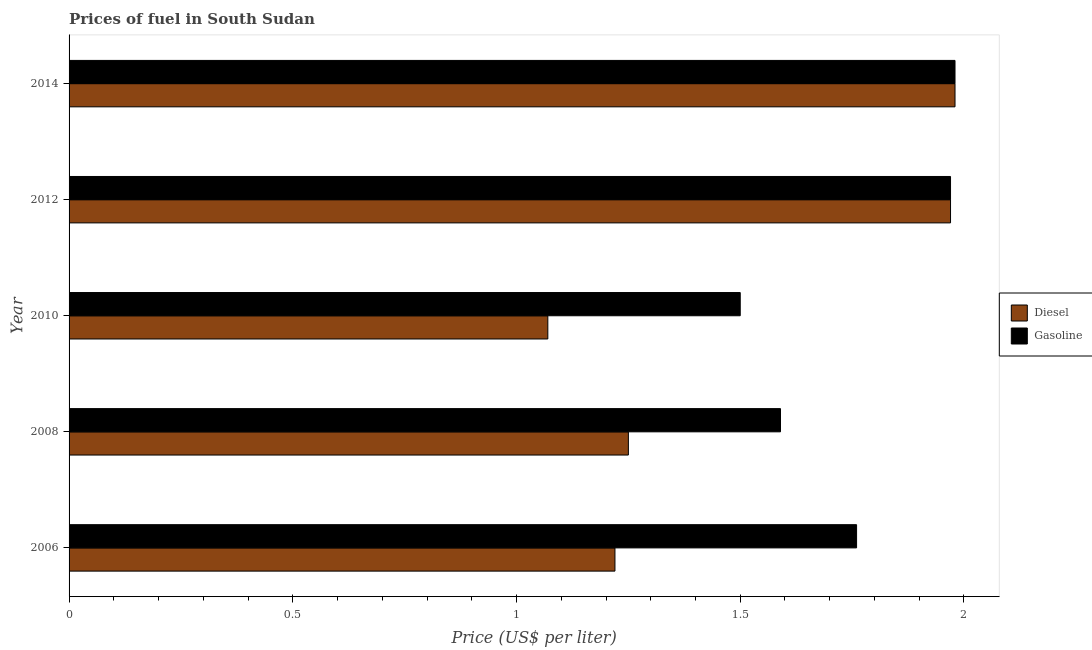How many groups of bars are there?
Your answer should be very brief. 5. Are the number of bars per tick equal to the number of legend labels?
Provide a succinct answer. Yes. How many bars are there on the 2nd tick from the bottom?
Make the answer very short. 2. What is the label of the 5th group of bars from the top?
Keep it short and to the point. 2006. In how many cases, is the number of bars for a given year not equal to the number of legend labels?
Give a very brief answer. 0. What is the diesel price in 2012?
Give a very brief answer. 1.97. Across all years, what is the maximum gasoline price?
Provide a succinct answer. 1.98. Across all years, what is the minimum diesel price?
Offer a terse response. 1.07. In which year was the diesel price minimum?
Make the answer very short. 2010. What is the total gasoline price in the graph?
Make the answer very short. 8.8. What is the difference between the gasoline price in 2012 and that in 2014?
Keep it short and to the point. -0.01. What is the difference between the gasoline price in 2006 and the diesel price in 2010?
Provide a short and direct response. 0.69. What is the average diesel price per year?
Your answer should be compact. 1.5. In the year 2012, what is the difference between the gasoline price and diesel price?
Your response must be concise. 0. In how many years, is the diesel price greater than 1.3 US$ per litre?
Provide a short and direct response. 2. What is the ratio of the diesel price in 2006 to that in 2010?
Ensure brevity in your answer.  1.14. Is the gasoline price in 2006 less than that in 2010?
Make the answer very short. No. Is the difference between the diesel price in 2008 and 2012 greater than the difference between the gasoline price in 2008 and 2012?
Ensure brevity in your answer.  No. What is the difference between the highest and the second highest diesel price?
Your answer should be very brief. 0.01. What is the difference between the highest and the lowest gasoline price?
Your response must be concise. 0.48. In how many years, is the diesel price greater than the average diesel price taken over all years?
Give a very brief answer. 2. What does the 2nd bar from the top in 2014 represents?
Make the answer very short. Diesel. What does the 2nd bar from the bottom in 2012 represents?
Offer a terse response. Gasoline. How many bars are there?
Provide a short and direct response. 10. Are the values on the major ticks of X-axis written in scientific E-notation?
Your answer should be compact. No. Does the graph contain any zero values?
Ensure brevity in your answer.  No. Does the graph contain grids?
Provide a succinct answer. No. How are the legend labels stacked?
Your answer should be compact. Vertical. What is the title of the graph?
Your response must be concise. Prices of fuel in South Sudan. What is the label or title of the X-axis?
Your answer should be very brief. Price (US$ per liter). What is the Price (US$ per liter) in Diesel in 2006?
Your answer should be very brief. 1.22. What is the Price (US$ per liter) in Gasoline in 2006?
Ensure brevity in your answer.  1.76. What is the Price (US$ per liter) of Diesel in 2008?
Offer a terse response. 1.25. What is the Price (US$ per liter) in Gasoline in 2008?
Keep it short and to the point. 1.59. What is the Price (US$ per liter) in Diesel in 2010?
Keep it short and to the point. 1.07. What is the Price (US$ per liter) of Diesel in 2012?
Make the answer very short. 1.97. What is the Price (US$ per liter) of Gasoline in 2012?
Ensure brevity in your answer.  1.97. What is the Price (US$ per liter) of Diesel in 2014?
Your answer should be compact. 1.98. What is the Price (US$ per liter) of Gasoline in 2014?
Keep it short and to the point. 1.98. Across all years, what is the maximum Price (US$ per liter) in Diesel?
Your response must be concise. 1.98. Across all years, what is the maximum Price (US$ per liter) of Gasoline?
Offer a terse response. 1.98. Across all years, what is the minimum Price (US$ per liter) in Diesel?
Provide a short and direct response. 1.07. What is the total Price (US$ per liter) of Diesel in the graph?
Offer a terse response. 7.49. What is the difference between the Price (US$ per liter) of Diesel in 2006 and that in 2008?
Ensure brevity in your answer.  -0.03. What is the difference between the Price (US$ per liter) in Gasoline in 2006 and that in 2008?
Provide a succinct answer. 0.17. What is the difference between the Price (US$ per liter) in Gasoline in 2006 and that in 2010?
Keep it short and to the point. 0.26. What is the difference between the Price (US$ per liter) in Diesel in 2006 and that in 2012?
Ensure brevity in your answer.  -0.75. What is the difference between the Price (US$ per liter) of Gasoline in 2006 and that in 2012?
Your response must be concise. -0.21. What is the difference between the Price (US$ per liter) in Diesel in 2006 and that in 2014?
Your answer should be very brief. -0.76. What is the difference between the Price (US$ per liter) in Gasoline in 2006 and that in 2014?
Your answer should be compact. -0.22. What is the difference between the Price (US$ per liter) in Diesel in 2008 and that in 2010?
Give a very brief answer. 0.18. What is the difference between the Price (US$ per liter) in Gasoline in 2008 and that in 2010?
Ensure brevity in your answer.  0.09. What is the difference between the Price (US$ per liter) of Diesel in 2008 and that in 2012?
Ensure brevity in your answer.  -0.72. What is the difference between the Price (US$ per liter) of Gasoline in 2008 and that in 2012?
Give a very brief answer. -0.38. What is the difference between the Price (US$ per liter) of Diesel in 2008 and that in 2014?
Your response must be concise. -0.73. What is the difference between the Price (US$ per liter) of Gasoline in 2008 and that in 2014?
Ensure brevity in your answer.  -0.39. What is the difference between the Price (US$ per liter) of Gasoline in 2010 and that in 2012?
Provide a succinct answer. -0.47. What is the difference between the Price (US$ per liter) in Diesel in 2010 and that in 2014?
Provide a short and direct response. -0.91. What is the difference between the Price (US$ per liter) of Gasoline in 2010 and that in 2014?
Give a very brief answer. -0.48. What is the difference between the Price (US$ per liter) in Diesel in 2012 and that in 2014?
Make the answer very short. -0.01. What is the difference between the Price (US$ per liter) in Gasoline in 2012 and that in 2014?
Provide a short and direct response. -0.01. What is the difference between the Price (US$ per liter) of Diesel in 2006 and the Price (US$ per liter) of Gasoline in 2008?
Keep it short and to the point. -0.37. What is the difference between the Price (US$ per liter) of Diesel in 2006 and the Price (US$ per liter) of Gasoline in 2010?
Provide a succinct answer. -0.28. What is the difference between the Price (US$ per liter) in Diesel in 2006 and the Price (US$ per liter) in Gasoline in 2012?
Keep it short and to the point. -0.75. What is the difference between the Price (US$ per liter) of Diesel in 2006 and the Price (US$ per liter) of Gasoline in 2014?
Offer a very short reply. -0.76. What is the difference between the Price (US$ per liter) of Diesel in 2008 and the Price (US$ per liter) of Gasoline in 2010?
Ensure brevity in your answer.  -0.25. What is the difference between the Price (US$ per liter) in Diesel in 2008 and the Price (US$ per liter) in Gasoline in 2012?
Ensure brevity in your answer.  -0.72. What is the difference between the Price (US$ per liter) of Diesel in 2008 and the Price (US$ per liter) of Gasoline in 2014?
Your answer should be compact. -0.73. What is the difference between the Price (US$ per liter) in Diesel in 2010 and the Price (US$ per liter) in Gasoline in 2012?
Provide a succinct answer. -0.9. What is the difference between the Price (US$ per liter) in Diesel in 2010 and the Price (US$ per liter) in Gasoline in 2014?
Provide a short and direct response. -0.91. What is the difference between the Price (US$ per liter) of Diesel in 2012 and the Price (US$ per liter) of Gasoline in 2014?
Your answer should be compact. -0.01. What is the average Price (US$ per liter) in Diesel per year?
Offer a terse response. 1.5. What is the average Price (US$ per liter) of Gasoline per year?
Offer a very short reply. 1.76. In the year 2006, what is the difference between the Price (US$ per liter) of Diesel and Price (US$ per liter) of Gasoline?
Your answer should be very brief. -0.54. In the year 2008, what is the difference between the Price (US$ per liter) of Diesel and Price (US$ per liter) of Gasoline?
Your answer should be compact. -0.34. In the year 2010, what is the difference between the Price (US$ per liter) in Diesel and Price (US$ per liter) in Gasoline?
Give a very brief answer. -0.43. In the year 2014, what is the difference between the Price (US$ per liter) of Diesel and Price (US$ per liter) of Gasoline?
Give a very brief answer. 0. What is the ratio of the Price (US$ per liter) of Diesel in 2006 to that in 2008?
Your answer should be compact. 0.98. What is the ratio of the Price (US$ per liter) of Gasoline in 2006 to that in 2008?
Make the answer very short. 1.11. What is the ratio of the Price (US$ per liter) of Diesel in 2006 to that in 2010?
Your response must be concise. 1.14. What is the ratio of the Price (US$ per liter) of Gasoline in 2006 to that in 2010?
Provide a short and direct response. 1.17. What is the ratio of the Price (US$ per liter) of Diesel in 2006 to that in 2012?
Ensure brevity in your answer.  0.62. What is the ratio of the Price (US$ per liter) in Gasoline in 2006 to that in 2012?
Offer a terse response. 0.89. What is the ratio of the Price (US$ per liter) of Diesel in 2006 to that in 2014?
Keep it short and to the point. 0.62. What is the ratio of the Price (US$ per liter) in Gasoline in 2006 to that in 2014?
Your answer should be compact. 0.89. What is the ratio of the Price (US$ per liter) in Diesel in 2008 to that in 2010?
Offer a very short reply. 1.17. What is the ratio of the Price (US$ per liter) of Gasoline in 2008 to that in 2010?
Your response must be concise. 1.06. What is the ratio of the Price (US$ per liter) of Diesel in 2008 to that in 2012?
Offer a very short reply. 0.63. What is the ratio of the Price (US$ per liter) of Gasoline in 2008 to that in 2012?
Give a very brief answer. 0.81. What is the ratio of the Price (US$ per liter) of Diesel in 2008 to that in 2014?
Offer a very short reply. 0.63. What is the ratio of the Price (US$ per liter) in Gasoline in 2008 to that in 2014?
Your answer should be compact. 0.8. What is the ratio of the Price (US$ per liter) of Diesel in 2010 to that in 2012?
Keep it short and to the point. 0.54. What is the ratio of the Price (US$ per liter) of Gasoline in 2010 to that in 2012?
Provide a succinct answer. 0.76. What is the ratio of the Price (US$ per liter) in Diesel in 2010 to that in 2014?
Ensure brevity in your answer.  0.54. What is the ratio of the Price (US$ per liter) of Gasoline in 2010 to that in 2014?
Keep it short and to the point. 0.76. What is the ratio of the Price (US$ per liter) of Diesel in 2012 to that in 2014?
Offer a very short reply. 0.99. What is the difference between the highest and the second highest Price (US$ per liter) in Diesel?
Your answer should be compact. 0.01. What is the difference between the highest and the lowest Price (US$ per liter) of Diesel?
Offer a terse response. 0.91. What is the difference between the highest and the lowest Price (US$ per liter) of Gasoline?
Make the answer very short. 0.48. 